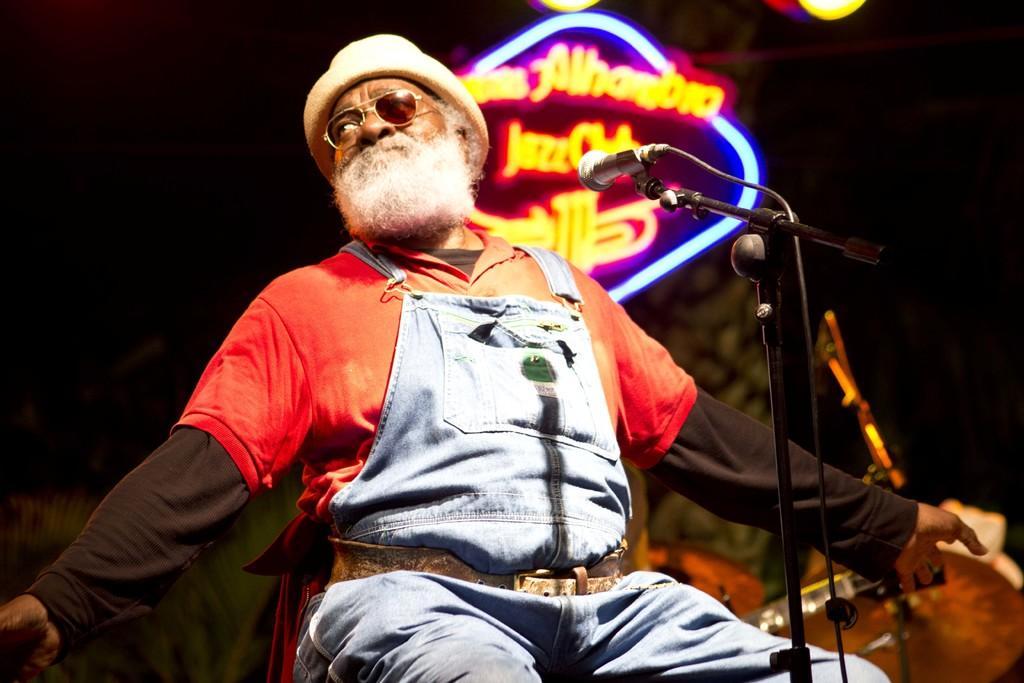In one or two sentences, can you explain what this image depicts? There is one man sitting and wearing goggles and a cap in the middle of this image. There is a Mic on the right side of this image, and there is a board with lights at the top of this image. 